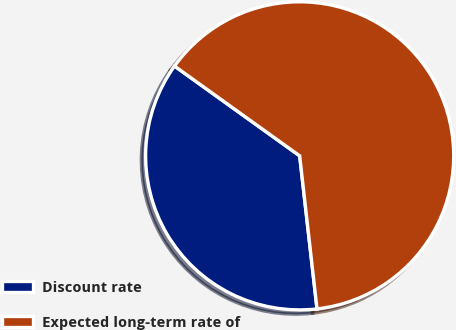<chart> <loc_0><loc_0><loc_500><loc_500><pie_chart><fcel>Discount rate<fcel>Expected long-term rate of<nl><fcel>36.7%<fcel>63.3%<nl></chart> 